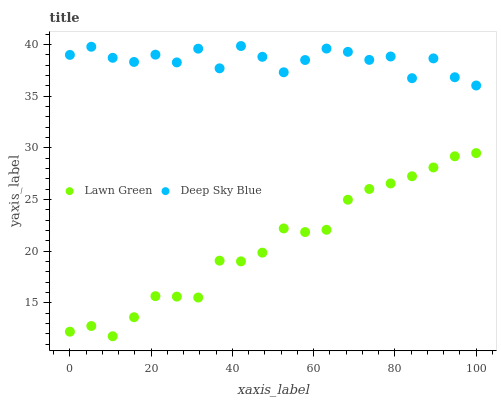Does Lawn Green have the minimum area under the curve?
Answer yes or no. Yes. Does Deep Sky Blue have the maximum area under the curve?
Answer yes or no. Yes. Does Deep Sky Blue have the minimum area under the curve?
Answer yes or no. No. Is Lawn Green the smoothest?
Answer yes or no. Yes. Is Deep Sky Blue the roughest?
Answer yes or no. Yes. Is Deep Sky Blue the smoothest?
Answer yes or no. No. Does Lawn Green have the lowest value?
Answer yes or no. Yes. Does Deep Sky Blue have the lowest value?
Answer yes or no. No. Does Deep Sky Blue have the highest value?
Answer yes or no. Yes. Is Lawn Green less than Deep Sky Blue?
Answer yes or no. Yes. Is Deep Sky Blue greater than Lawn Green?
Answer yes or no. Yes. Does Lawn Green intersect Deep Sky Blue?
Answer yes or no. No. 